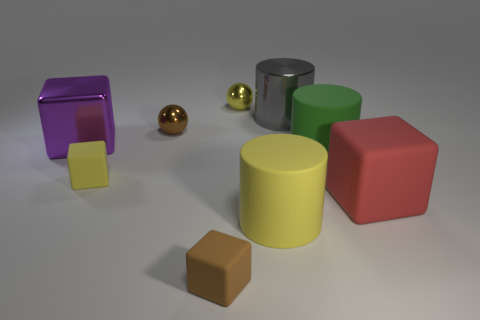Subtract all blocks. How many objects are left? 5 Add 1 shiny things. How many shiny things are left? 5 Add 6 yellow rubber things. How many yellow rubber things exist? 8 Subtract 1 brown cubes. How many objects are left? 8 Subtract all purple rubber cylinders. Subtract all brown spheres. How many objects are left? 8 